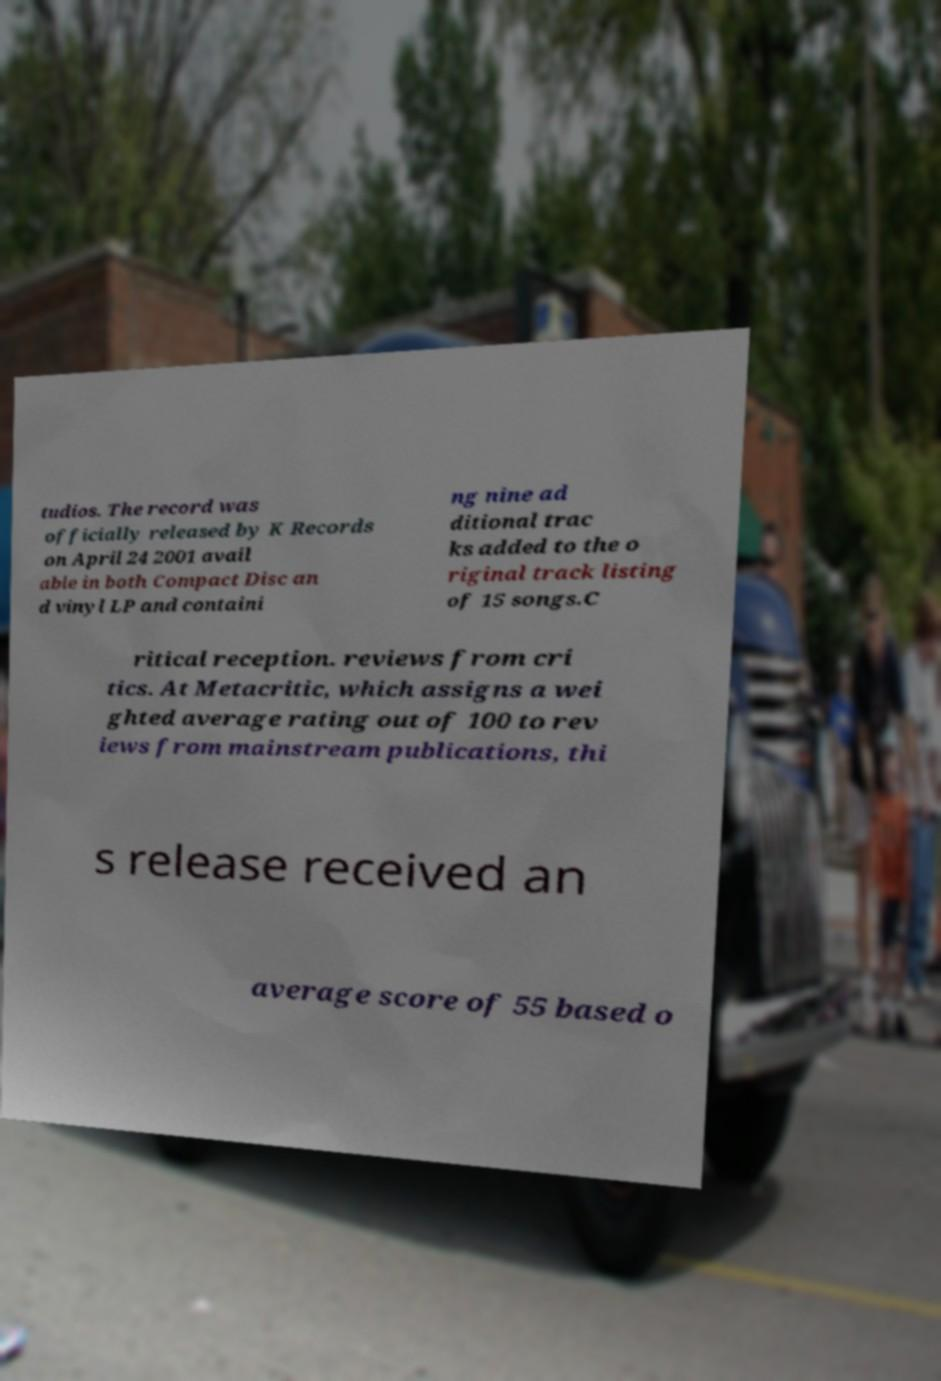Could you extract and type out the text from this image? tudios. The record was officially released by K Records on April 24 2001 avail able in both Compact Disc an d vinyl LP and containi ng nine ad ditional trac ks added to the o riginal track listing of 15 songs.C ritical reception. reviews from cri tics. At Metacritic, which assigns a wei ghted average rating out of 100 to rev iews from mainstream publications, thi s release received an average score of 55 based o 